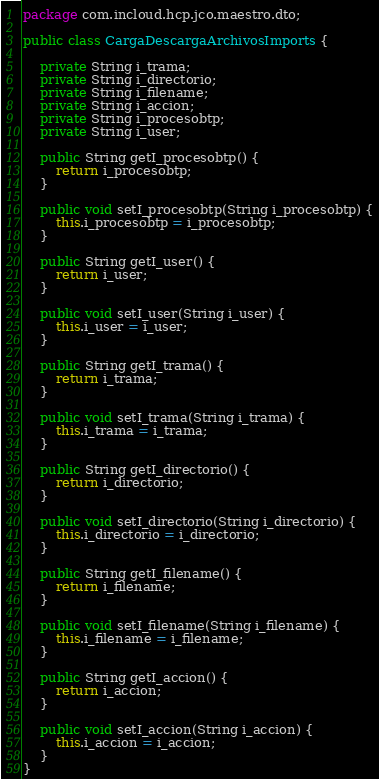Convert code to text. <code><loc_0><loc_0><loc_500><loc_500><_Java_>package com.incloud.hcp.jco.maestro.dto;

public class CargaDescargaArchivosImports {

    private String i_trama;
    private String i_directorio;
    private String i_filename;
    private String i_accion;
    private String i_procesobtp;
    private String i_user;

    public String getI_procesobtp() {
        return i_procesobtp;
    }

    public void setI_procesobtp(String i_procesobtp) {
        this.i_procesobtp = i_procesobtp;
    }

    public String getI_user() {
        return i_user;
    }

    public void setI_user(String i_user) {
        this.i_user = i_user;
    }

    public String getI_trama() {
        return i_trama;
    }

    public void setI_trama(String i_trama) {
        this.i_trama = i_trama;
    }

    public String getI_directorio() {
        return i_directorio;
    }

    public void setI_directorio(String i_directorio) {
        this.i_directorio = i_directorio;
    }

    public String getI_filename() {
        return i_filename;
    }

    public void setI_filename(String i_filename) {
        this.i_filename = i_filename;
    }

    public String getI_accion() {
        return i_accion;
    }

    public void setI_accion(String i_accion) {
        this.i_accion = i_accion;
    }
}
</code> 